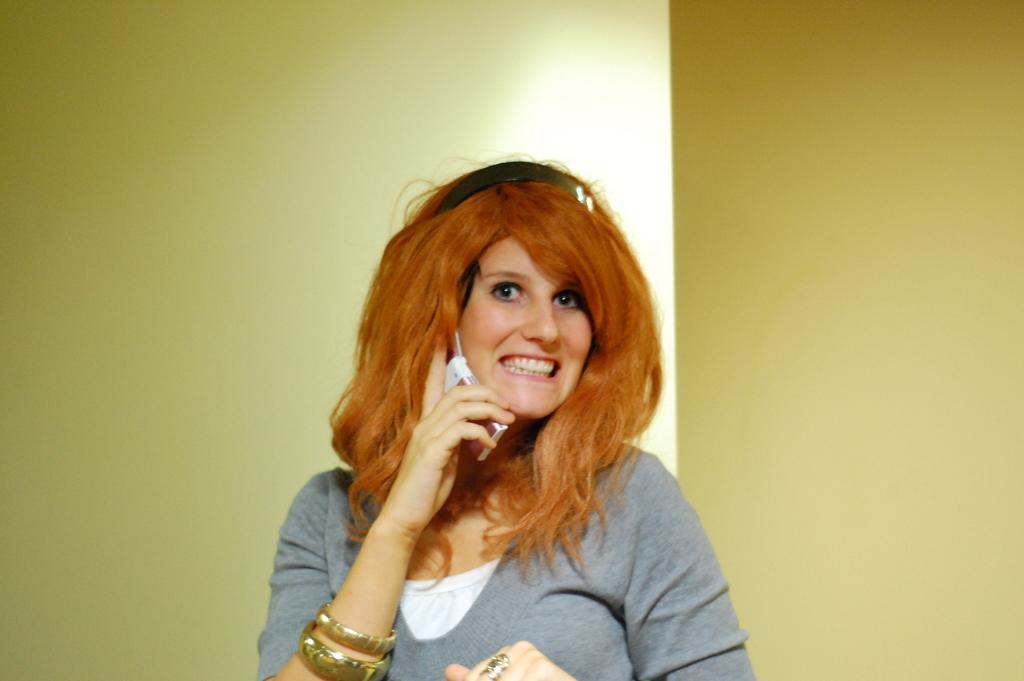What is the main subject of the image? The main subject of the image is a woman. What is the woman holding in the image? The woman is holding a mobile phone. What can be seen in the background of the image? There is a wall visible in the image. What type of quartz can be seen embedded in the ground in the image? There is no quartz present in the image, and the ground is not visible. 